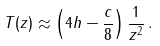<formula> <loc_0><loc_0><loc_500><loc_500>T ( z ) \approx \left ( 4 h - \frac { c } { 8 } \right ) \frac { 1 } { z ^ { 2 } } \, .</formula> 